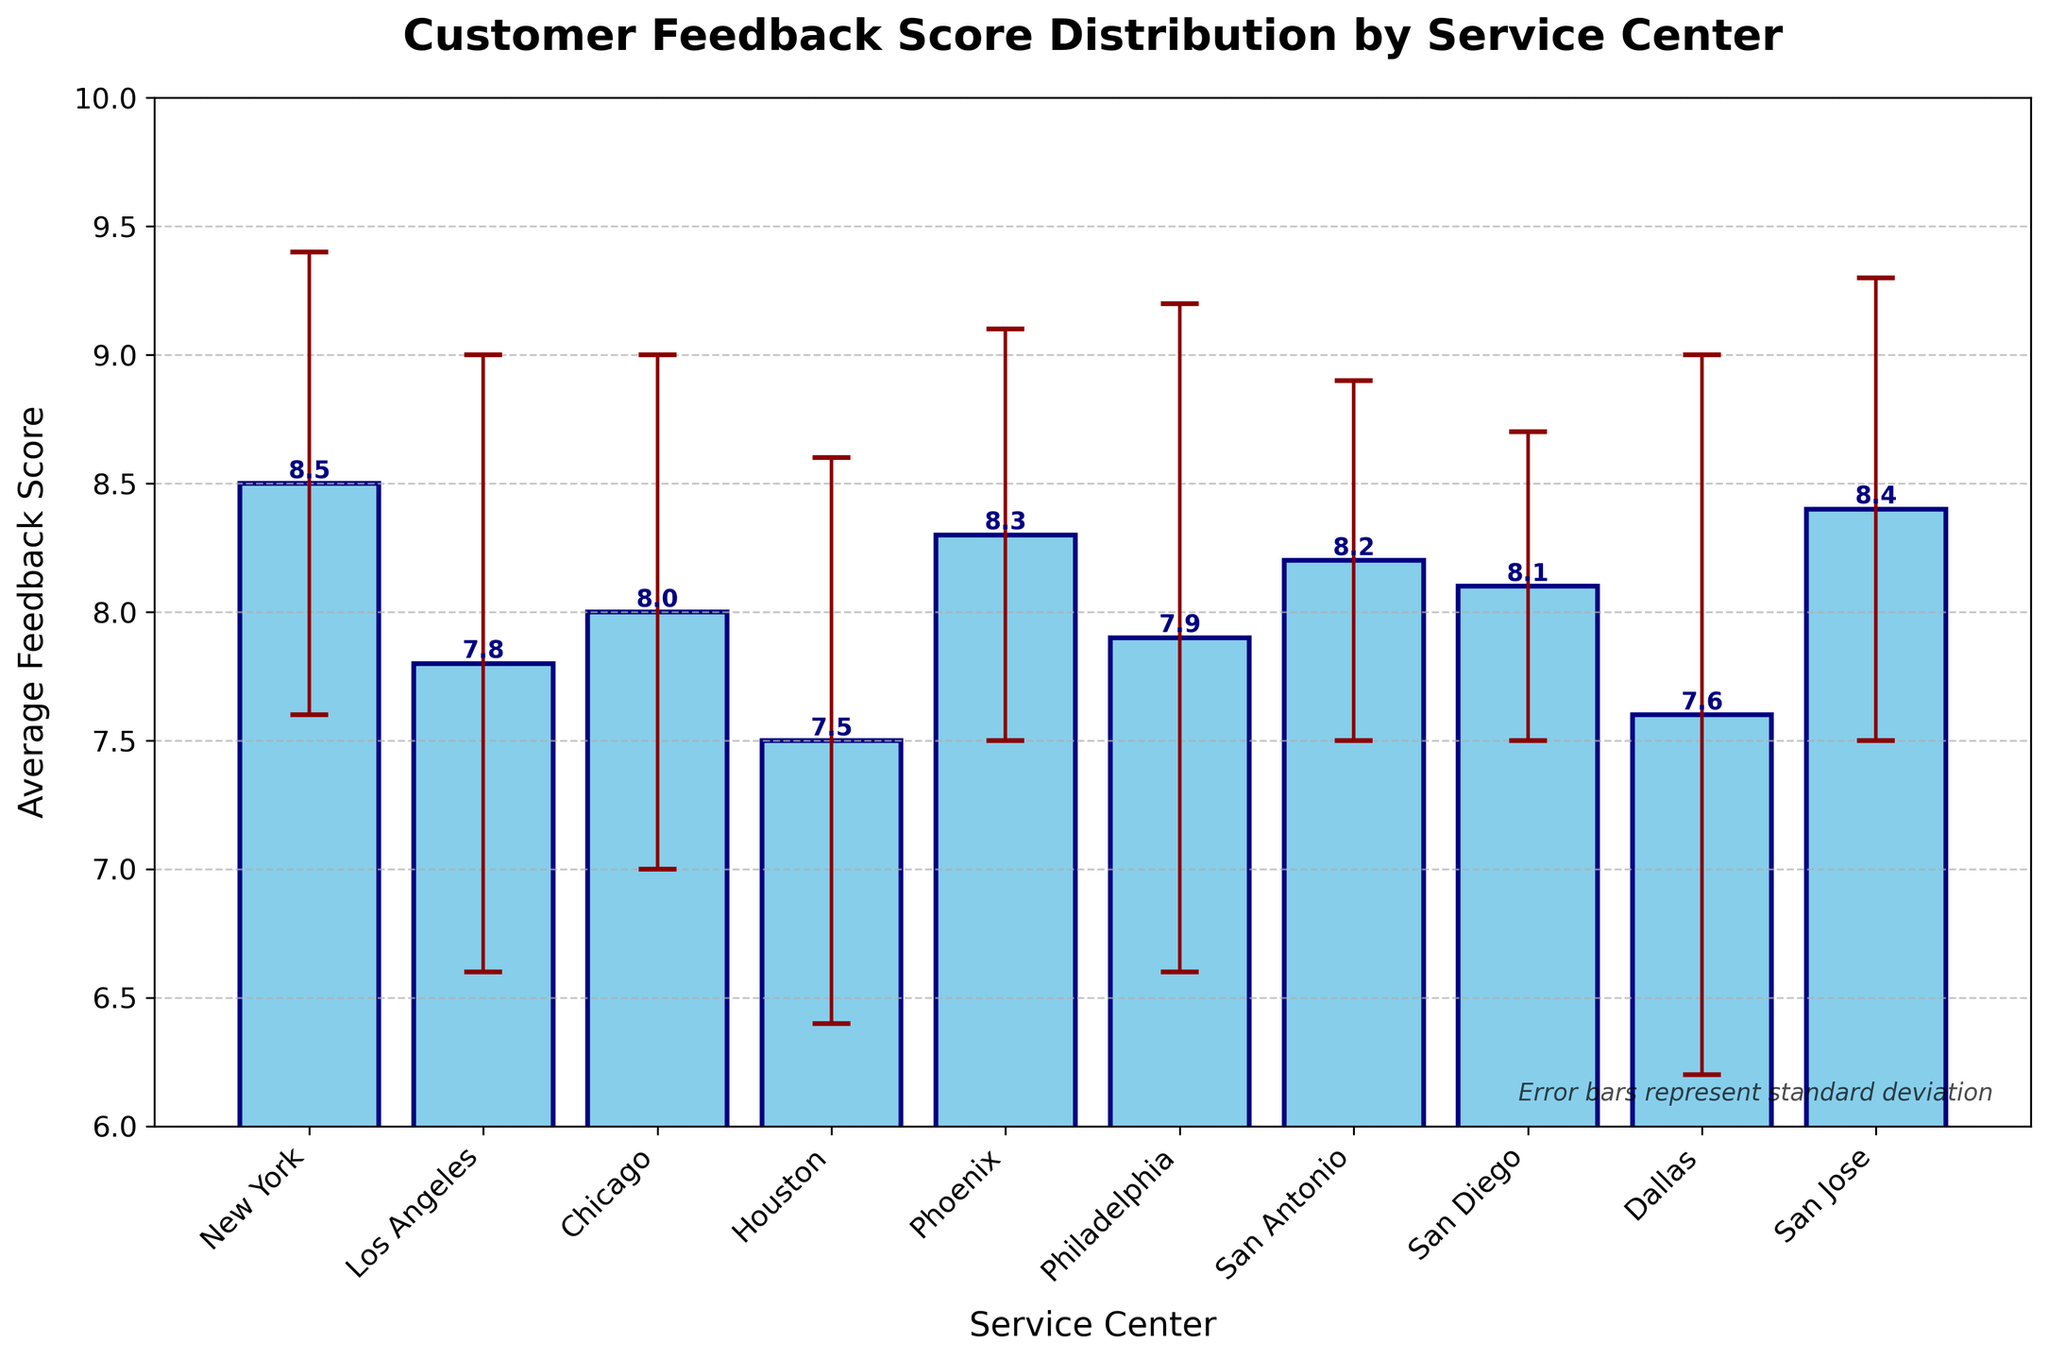Which service center has the highest average feedback score? The New York service center has an average feedback score of 8.5, which is the highest among all the centers.
Answer: New York What is the average feedback score for the Houston service center? According to the bar chart, the average feedback score for the Houston service center is shown as 7.5.
Answer: 7.5 How many service centers have an average feedback score above 8? By looking at the bars on the chart, we can identify that the service centers with scores above 8 are New York, Chicago, Phoenix, San Antonio, San Diego, and San Jose. This makes a total of 6 service centers.
Answer: 6 Which service center has the largest standard deviation? By observing the error bars, the largest standard deviation is for the Dallas service center, with an error bar stretching to 1.4 units.
Answer: Dallas What is the difference in average feedback score between the highest and lowest scoring service centers? The highest average feedback score is 8.5 (New York), and the lowest is 7.5 (Houston). The difference is calculated as 8.5 - 7.5 = 1.0.
Answer: 1.0 What is the combined average feedback score for Los Angeles and Chicago? The average feedback score for Los Angeles is 7.8 and for Chicago is 8.0. Adding these gives 7.8 + 8.0 = 15.8.
Answer: 15.8 Which two service centers have the closest average feedback scores? San Diego and Chicago have very close average feedback scores of 8.1 and 8.0, respectively. The difference is only 0.1.
Answer: San Diego and Chicago How do the error bars inform us about the feedback score reliability for Philadelphia and San Diego? Philadelphia's error bars are much larger (1.3) compared to San Diego's (0.6), indicating that the feedback scores in Philadelphia are more variable and less reliable compared to San Diego's more consistent feedback scores.
Answer: Philadelphia has more variability What is the median average feedback score of the service centers? Order the average feedback scores: 7.5, 7.6, 7.8, 7.9, 8.0, 8.1, 8.2, 8.3, 8.4, 8.5. Since there are 10 centers, the median is the average of the 5th and 6th values: (8.0 + 8.1)/2 = 8.05.
Answer: 8.05 If we wanted to achieve an average feedback score above 8 across all service centers, which centers need to improve their scores? Comparing to 8, the centers below 8 are Los Angeles (7.8), Houston (7.5), Philadelphia (7.9), and Dallas (7.6). These centers need to improve to raise the overall average above 8.
Answer: Los Angeles, Houston, Philadelphia, Dallas 